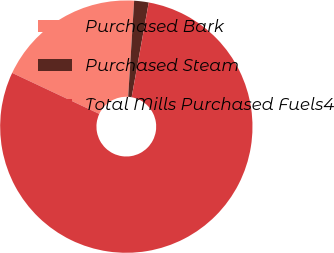Convert chart. <chart><loc_0><loc_0><loc_500><loc_500><pie_chart><fcel>Purchased Bark<fcel>Purchased Steam<fcel>Total Mills Purchased Fuels4<nl><fcel>18.99%<fcel>1.86%<fcel>79.15%<nl></chart> 